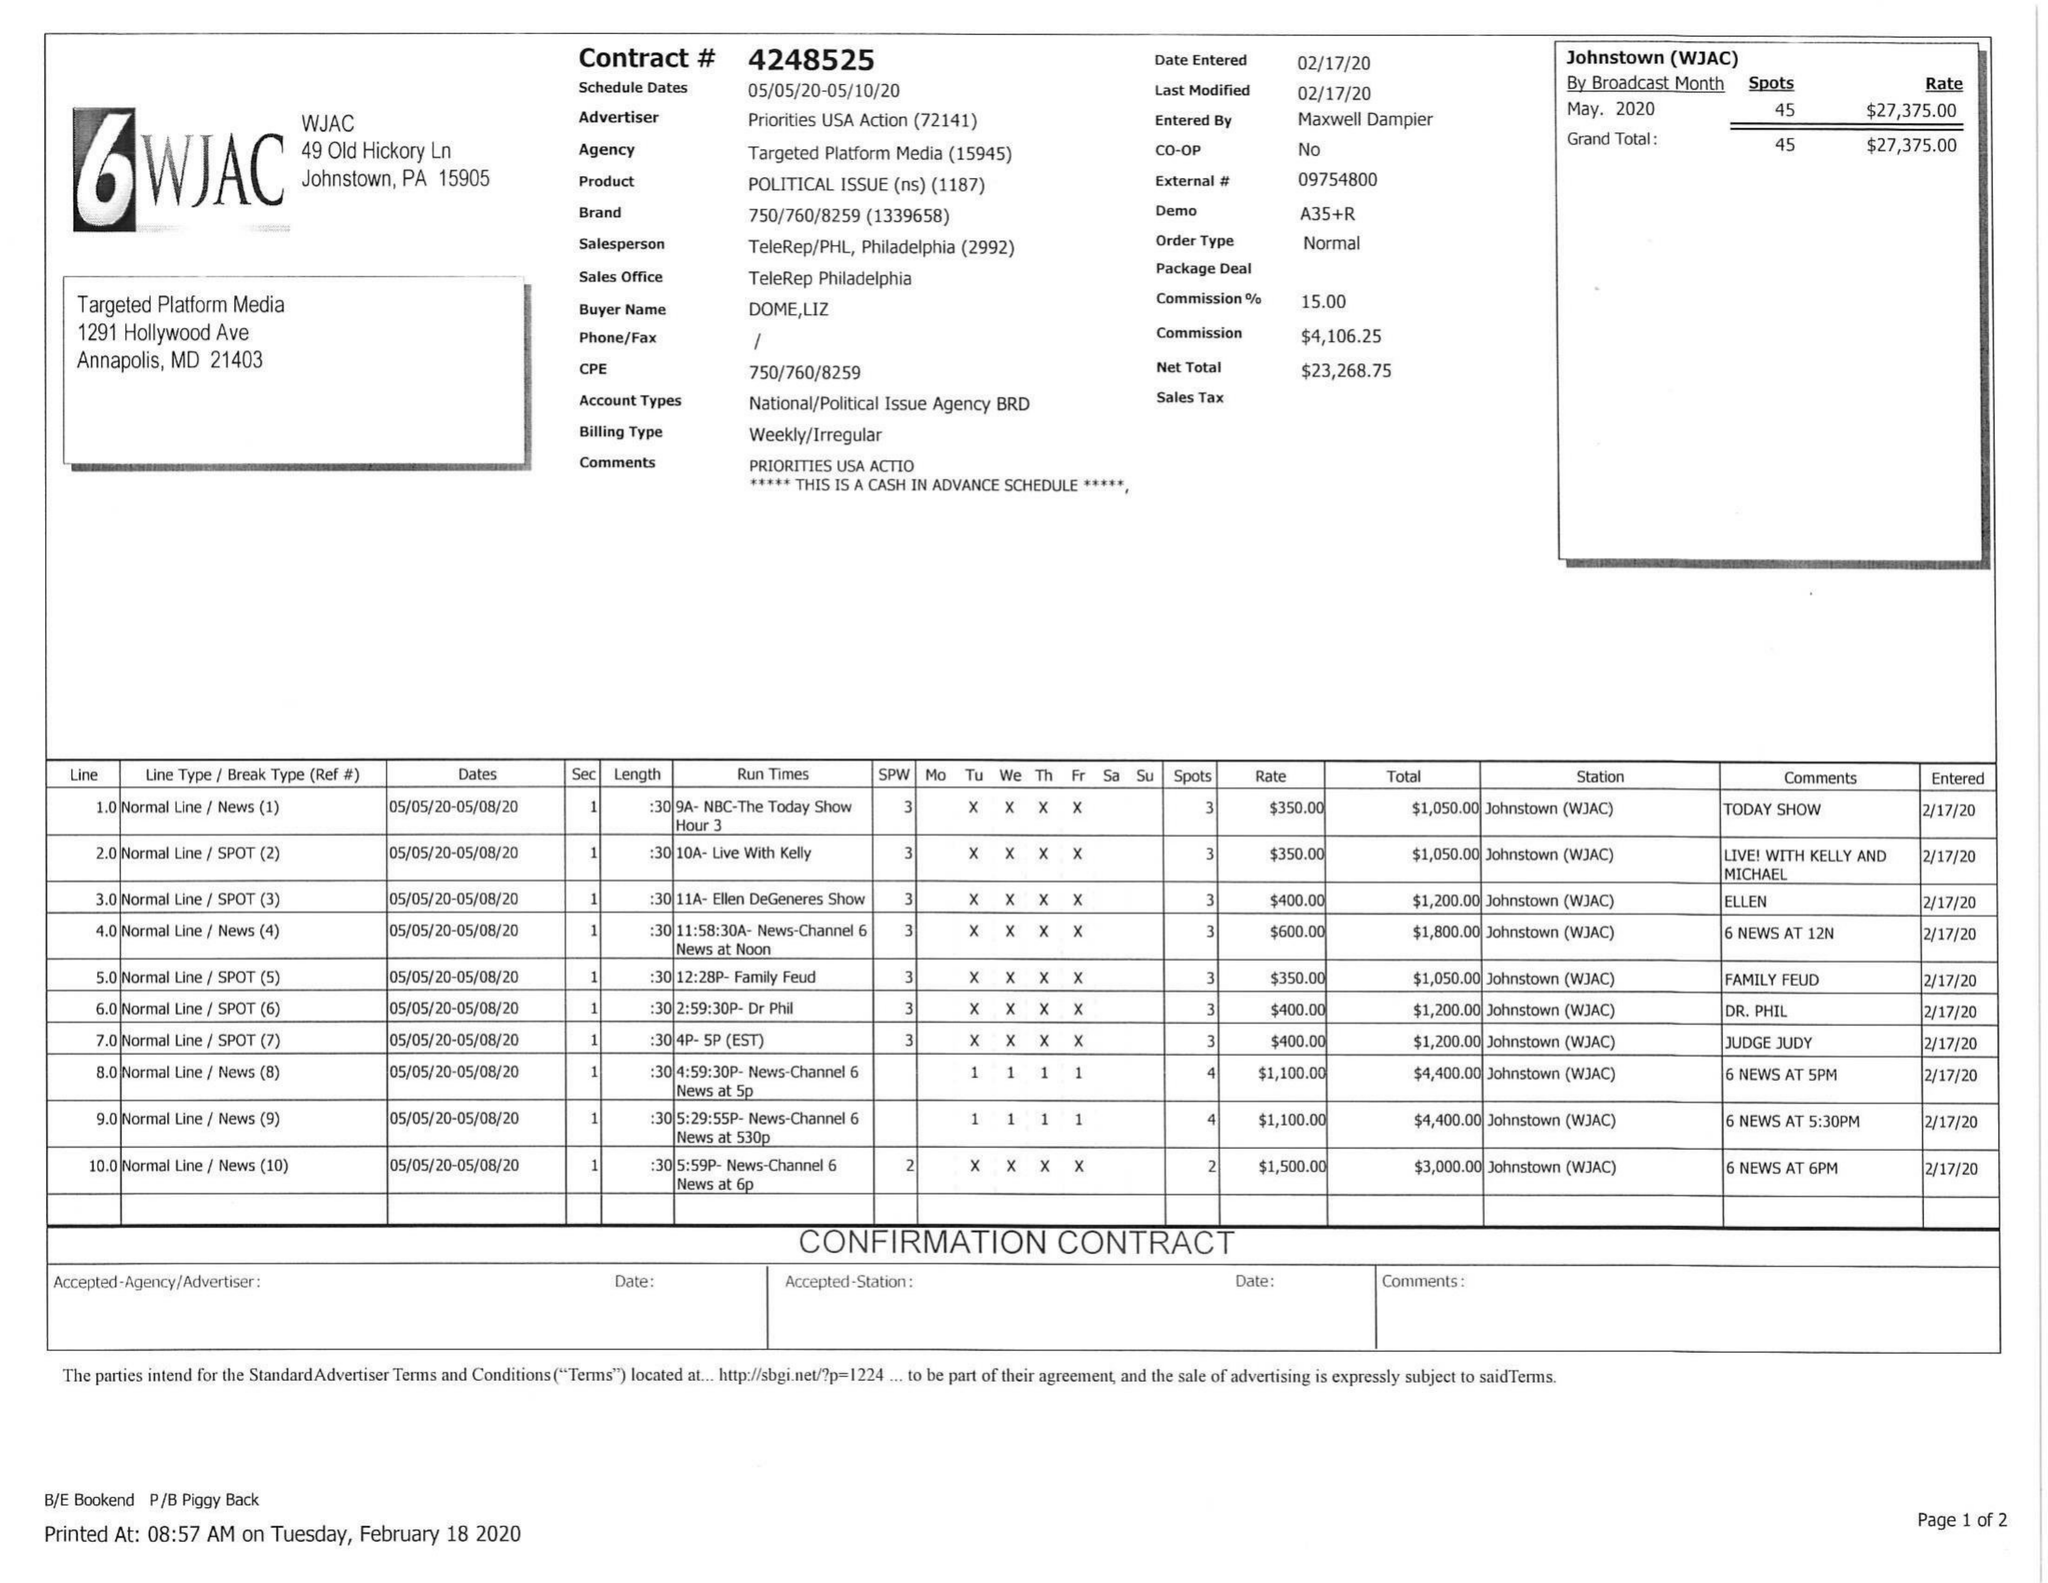What is the value for the gross_amount?
Answer the question using a single word or phrase. 27375.00 